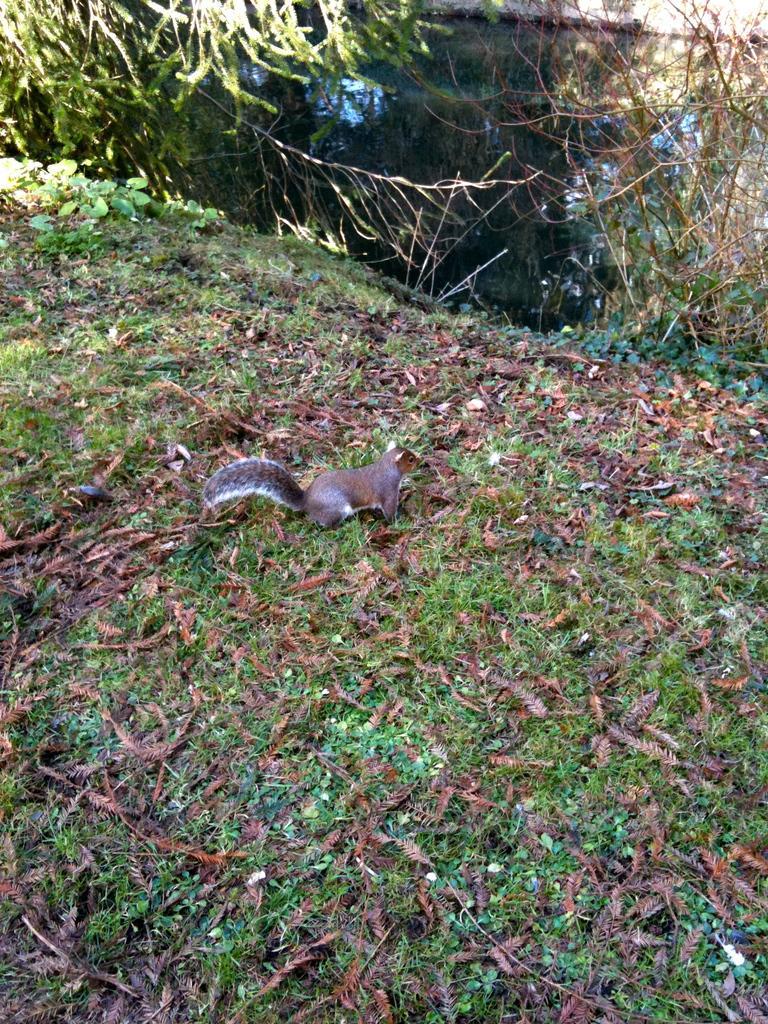In one or two sentences, can you explain what this image depicts? There is a squirrel on the ground. On the ground there are dried leaves and plants. At the top there is water and branches of a tree. Also there is a plant. 